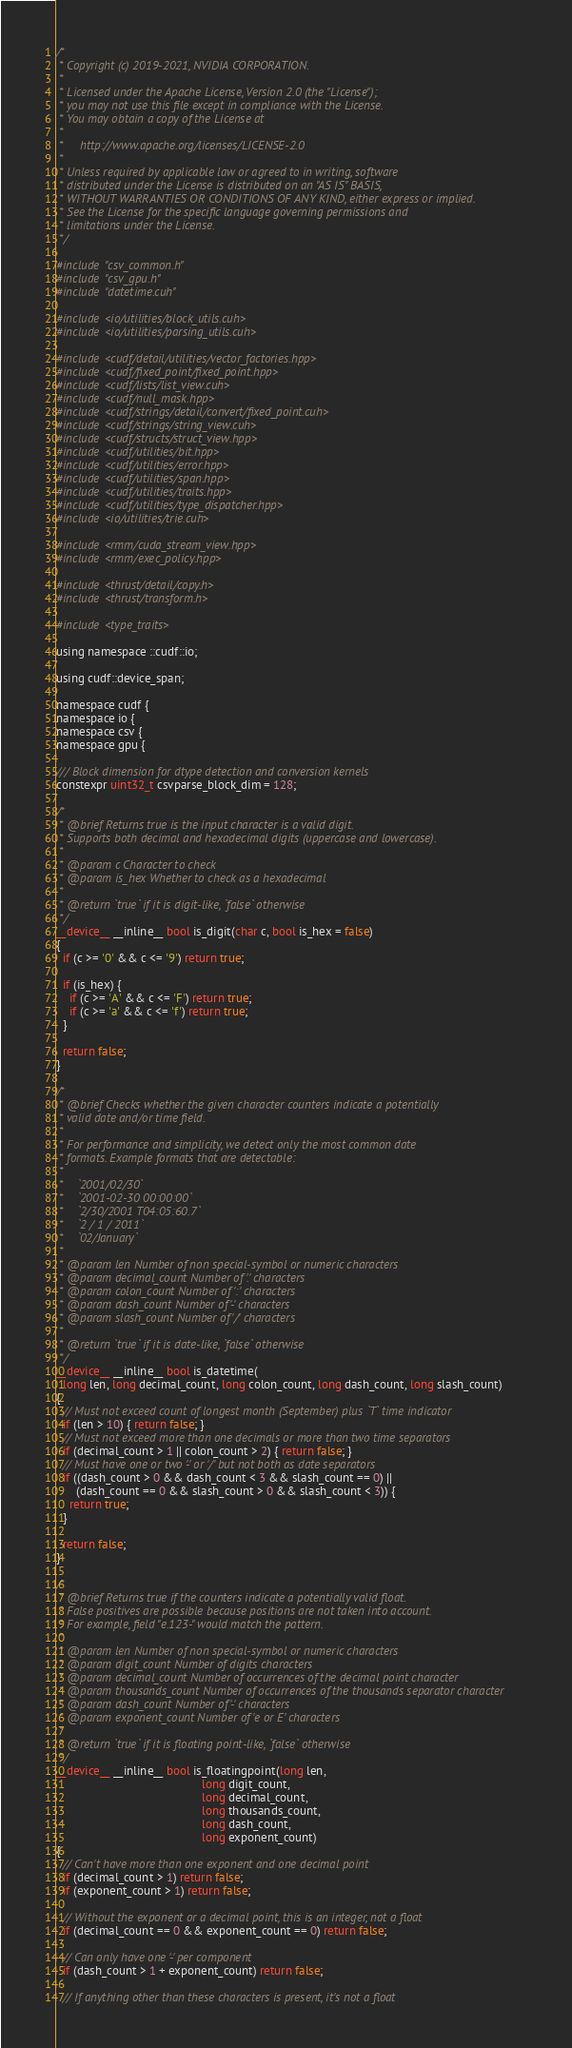Convert code to text. <code><loc_0><loc_0><loc_500><loc_500><_Cuda_>/*
 * Copyright (c) 2019-2021, NVIDIA CORPORATION.
 *
 * Licensed under the Apache License, Version 2.0 (the "License");
 * you may not use this file except in compliance with the License.
 * You may obtain a copy of the License at
 *
 *     http://www.apache.org/licenses/LICENSE-2.0
 *
 * Unless required by applicable law or agreed to in writing, software
 * distributed under the License is distributed on an "AS IS" BASIS,
 * WITHOUT WARRANTIES OR CONDITIONS OF ANY KIND, either express or implied.
 * See the License for the specific language governing permissions and
 * limitations under the License.
 */

#include "csv_common.h"
#include "csv_gpu.h"
#include "datetime.cuh"

#include <io/utilities/block_utils.cuh>
#include <io/utilities/parsing_utils.cuh>

#include <cudf/detail/utilities/vector_factories.hpp>
#include <cudf/fixed_point/fixed_point.hpp>
#include <cudf/lists/list_view.cuh>
#include <cudf/null_mask.hpp>
#include <cudf/strings/detail/convert/fixed_point.cuh>
#include <cudf/strings/string_view.cuh>
#include <cudf/structs/struct_view.hpp>
#include <cudf/utilities/bit.hpp>
#include <cudf/utilities/error.hpp>
#include <cudf/utilities/span.hpp>
#include <cudf/utilities/traits.hpp>
#include <cudf/utilities/type_dispatcher.hpp>
#include <io/utilities/trie.cuh>

#include <rmm/cuda_stream_view.hpp>
#include <rmm/exec_policy.hpp>

#include <thrust/detail/copy.h>
#include <thrust/transform.h>

#include <type_traits>

using namespace ::cudf::io;

using cudf::device_span;

namespace cudf {
namespace io {
namespace csv {
namespace gpu {

/// Block dimension for dtype detection and conversion kernels
constexpr uint32_t csvparse_block_dim = 128;

/*
 * @brief Returns true is the input character is a valid digit.
 * Supports both decimal and hexadecimal digits (uppercase and lowercase).
 *
 * @param c Character to check
 * @param is_hex Whether to check as a hexadecimal
 *
 * @return `true` if it is digit-like, `false` otherwise
 */
__device__ __inline__ bool is_digit(char c, bool is_hex = false)
{
  if (c >= '0' && c <= '9') return true;

  if (is_hex) {
    if (c >= 'A' && c <= 'F') return true;
    if (c >= 'a' && c <= 'f') return true;
  }

  return false;
}

/*
 * @brief Checks whether the given character counters indicate a potentially
 * valid date and/or time field.
 *
 * For performance and simplicity, we detect only the most common date
 * formats. Example formats that are detectable:
 *
 *    `2001/02/30`
 *    `2001-02-30 00:00:00`
 *    `2/30/2001 T04:05:60.7`
 *    `2 / 1 / 2011`
 *    `02/January`
 *
 * @param len Number of non special-symbol or numeric characters
 * @param decimal_count Number of '.' characters
 * @param colon_count Number of ':' characters
 * @param dash_count Number of '-' characters
 * @param slash_count Number of '/' characters
 *
 * @return `true` if it is date-like, `false` otherwise
 */
__device__ __inline__ bool is_datetime(
  long len, long decimal_count, long colon_count, long dash_count, long slash_count)
{
  // Must not exceed count of longest month (September) plus `T` time indicator
  if (len > 10) { return false; }
  // Must not exceed more than one decimals or more than two time separators
  if (decimal_count > 1 || colon_count > 2) { return false; }
  // Must have one or two '-' or '/' but not both as date separators
  if ((dash_count > 0 && dash_count < 3 && slash_count == 0) ||
      (dash_count == 0 && slash_count > 0 && slash_count < 3)) {
    return true;
  }

  return false;
}

/*
 * @brief Returns true if the counters indicate a potentially valid float.
 * False positives are possible because positions are not taken into account.
 * For example, field "e.123-" would match the pattern.
 *
 * @param len Number of non special-symbol or numeric characters
 * @param digit_count Number of digits characters
 * @param decimal_count Number of occurrences of the decimal point character
 * @param thousands_count Number of occurrences of the thousands separator character
 * @param dash_count Number of '-' characters
 * @param exponent_count Number of 'e or E' characters
 *
 * @return `true` if it is floating point-like, `false` otherwise
 */
__device__ __inline__ bool is_floatingpoint(long len,
                                            long digit_count,
                                            long decimal_count,
                                            long thousands_count,
                                            long dash_count,
                                            long exponent_count)
{
  // Can't have more than one exponent and one decimal point
  if (decimal_count > 1) return false;
  if (exponent_count > 1) return false;

  // Without the exponent or a decimal point, this is an integer, not a float
  if (decimal_count == 0 && exponent_count == 0) return false;

  // Can only have one '-' per component
  if (dash_count > 1 + exponent_count) return false;

  // If anything other than these characters is present, it's not a float</code> 